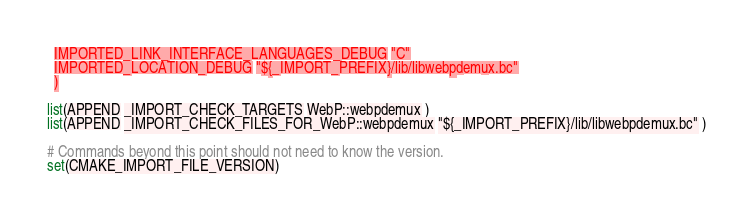<code> <loc_0><loc_0><loc_500><loc_500><_CMake_>  IMPORTED_LINK_INTERFACE_LANGUAGES_DEBUG "C"
  IMPORTED_LOCATION_DEBUG "${_IMPORT_PREFIX}/lib/libwebpdemux.bc"
  )

list(APPEND _IMPORT_CHECK_TARGETS WebP::webpdemux )
list(APPEND _IMPORT_CHECK_FILES_FOR_WebP::webpdemux "${_IMPORT_PREFIX}/lib/libwebpdemux.bc" )

# Commands beyond this point should not need to know the version.
set(CMAKE_IMPORT_FILE_VERSION)
</code> 